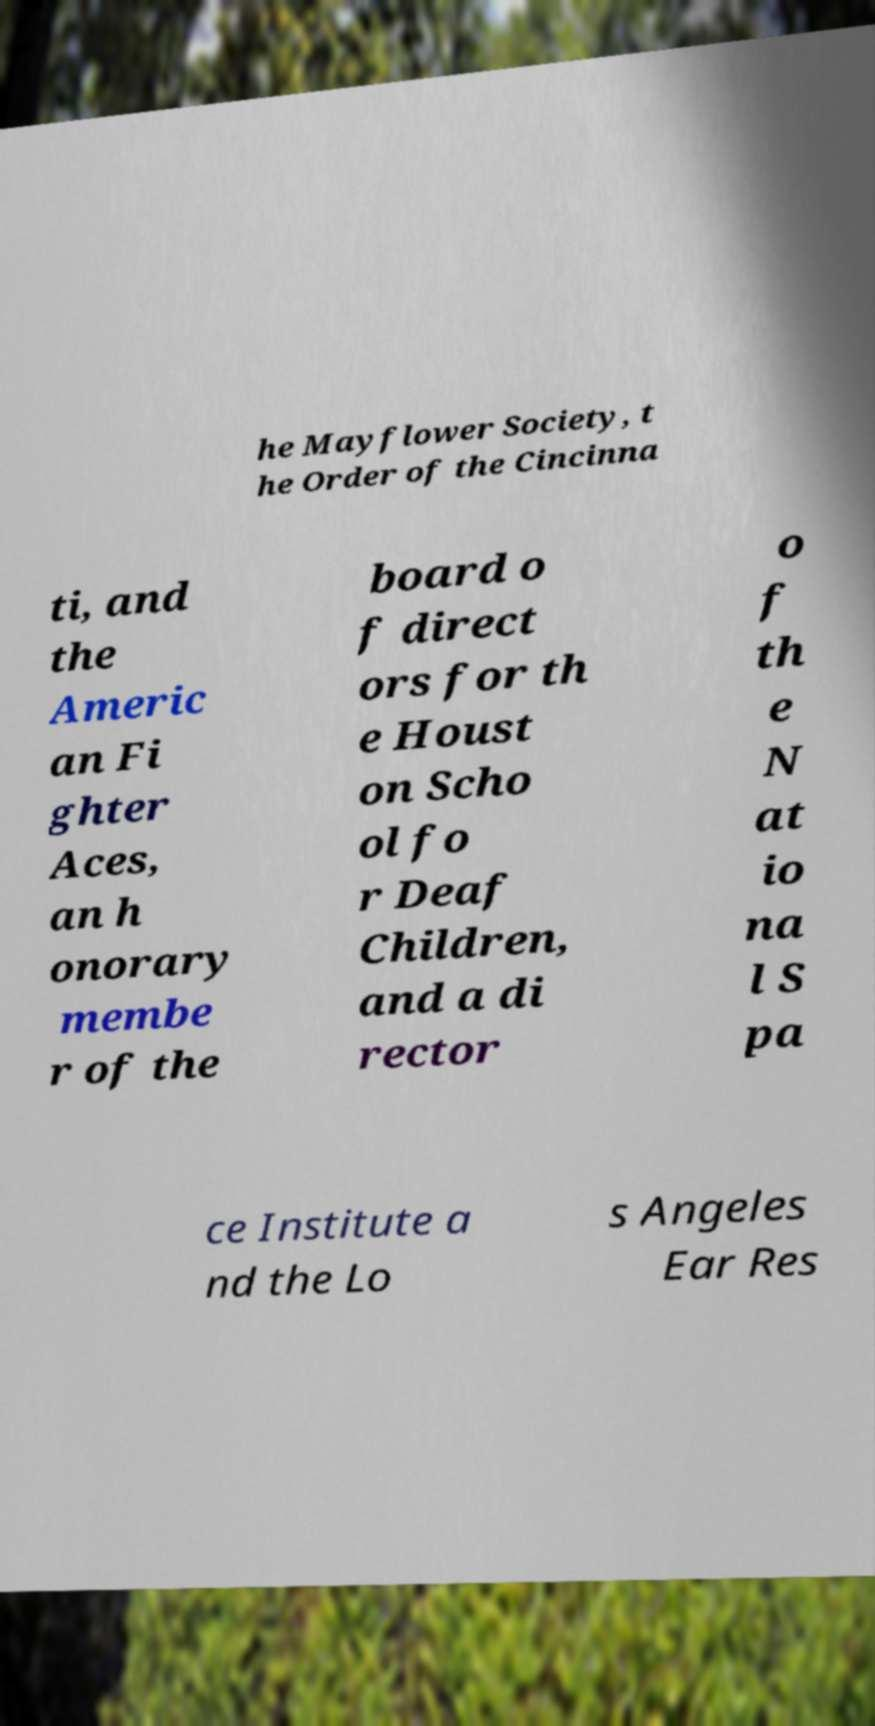Could you extract and type out the text from this image? he Mayflower Society, t he Order of the Cincinna ti, and the Americ an Fi ghter Aces, an h onorary membe r of the board o f direct ors for th e Houst on Scho ol fo r Deaf Children, and a di rector o f th e N at io na l S pa ce Institute a nd the Lo s Angeles Ear Res 